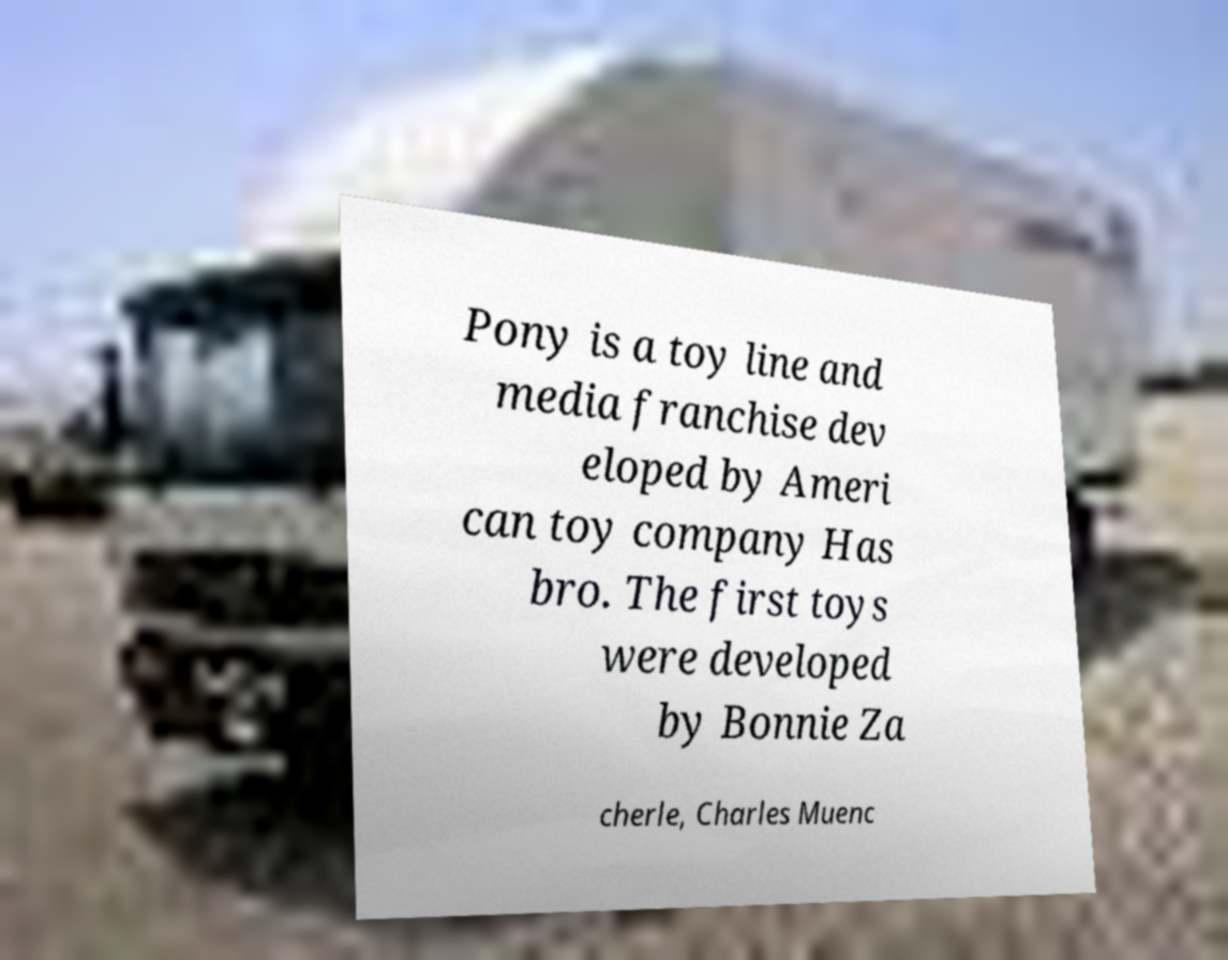What messages or text are displayed in this image? I need them in a readable, typed format. Pony is a toy line and media franchise dev eloped by Ameri can toy company Has bro. The first toys were developed by Bonnie Za cherle, Charles Muenc 